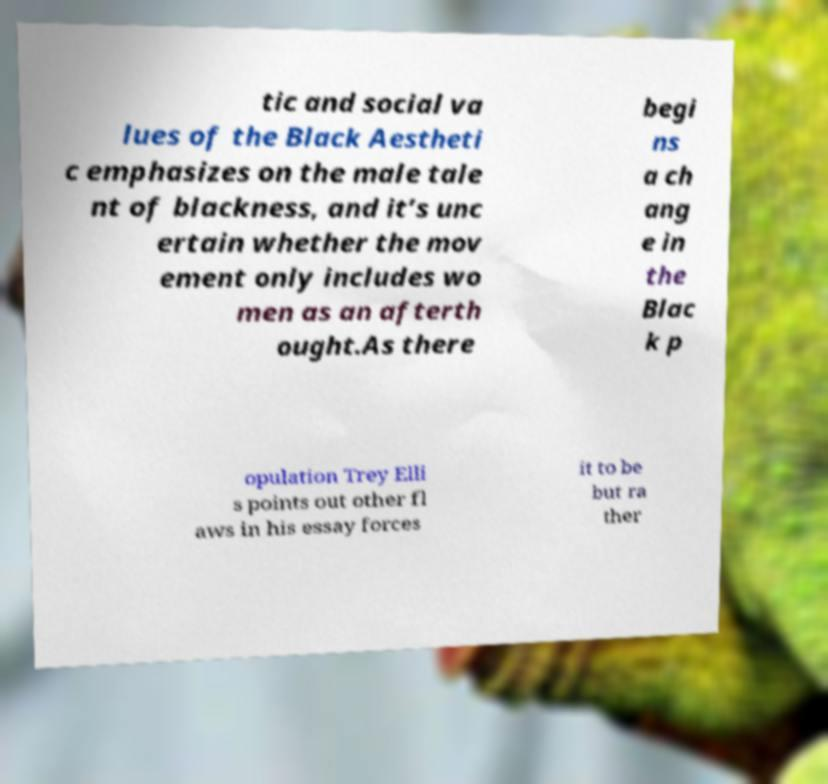Can you accurately transcribe the text from the provided image for me? tic and social va lues of the Black Aestheti c emphasizes on the male tale nt of blackness, and it’s unc ertain whether the mov ement only includes wo men as an afterth ought.As there begi ns a ch ang e in the Blac k p opulation Trey Elli s points out other fl aws in his essay forces it to be but ra ther 